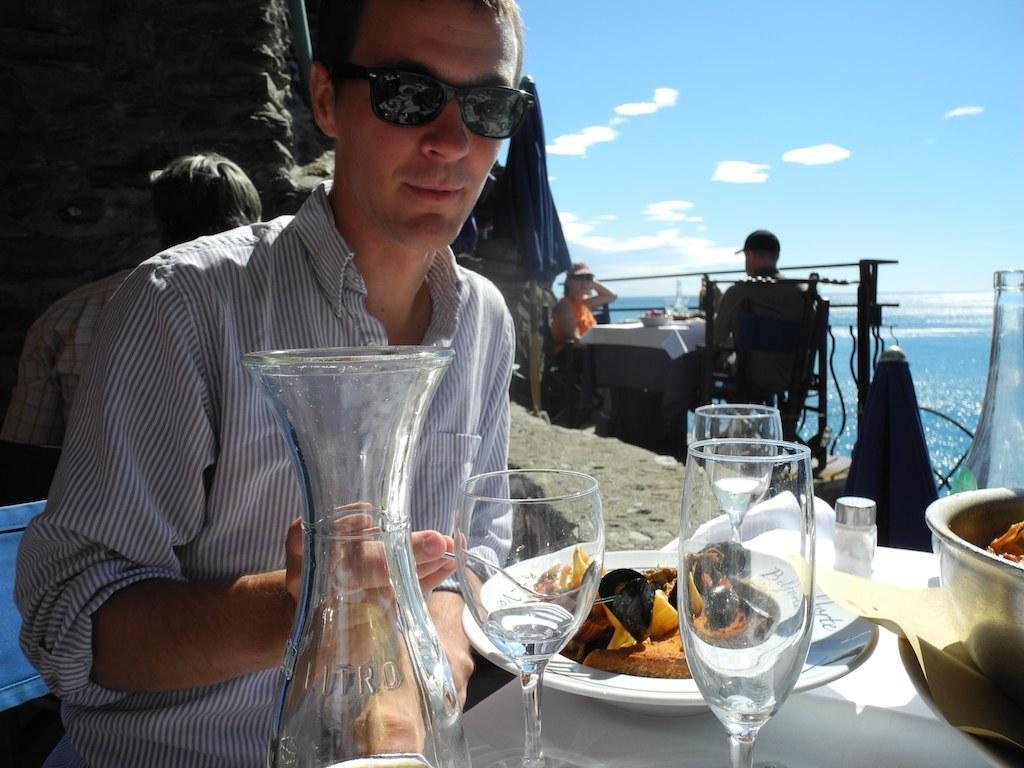How would you summarize this image in a sentence or two? In this image I can see a group of people, table, glasses, plates, bowl and benches on the beach. In the background I can see water, mountain and the sky. This image is taken may be on the sandy beach. 